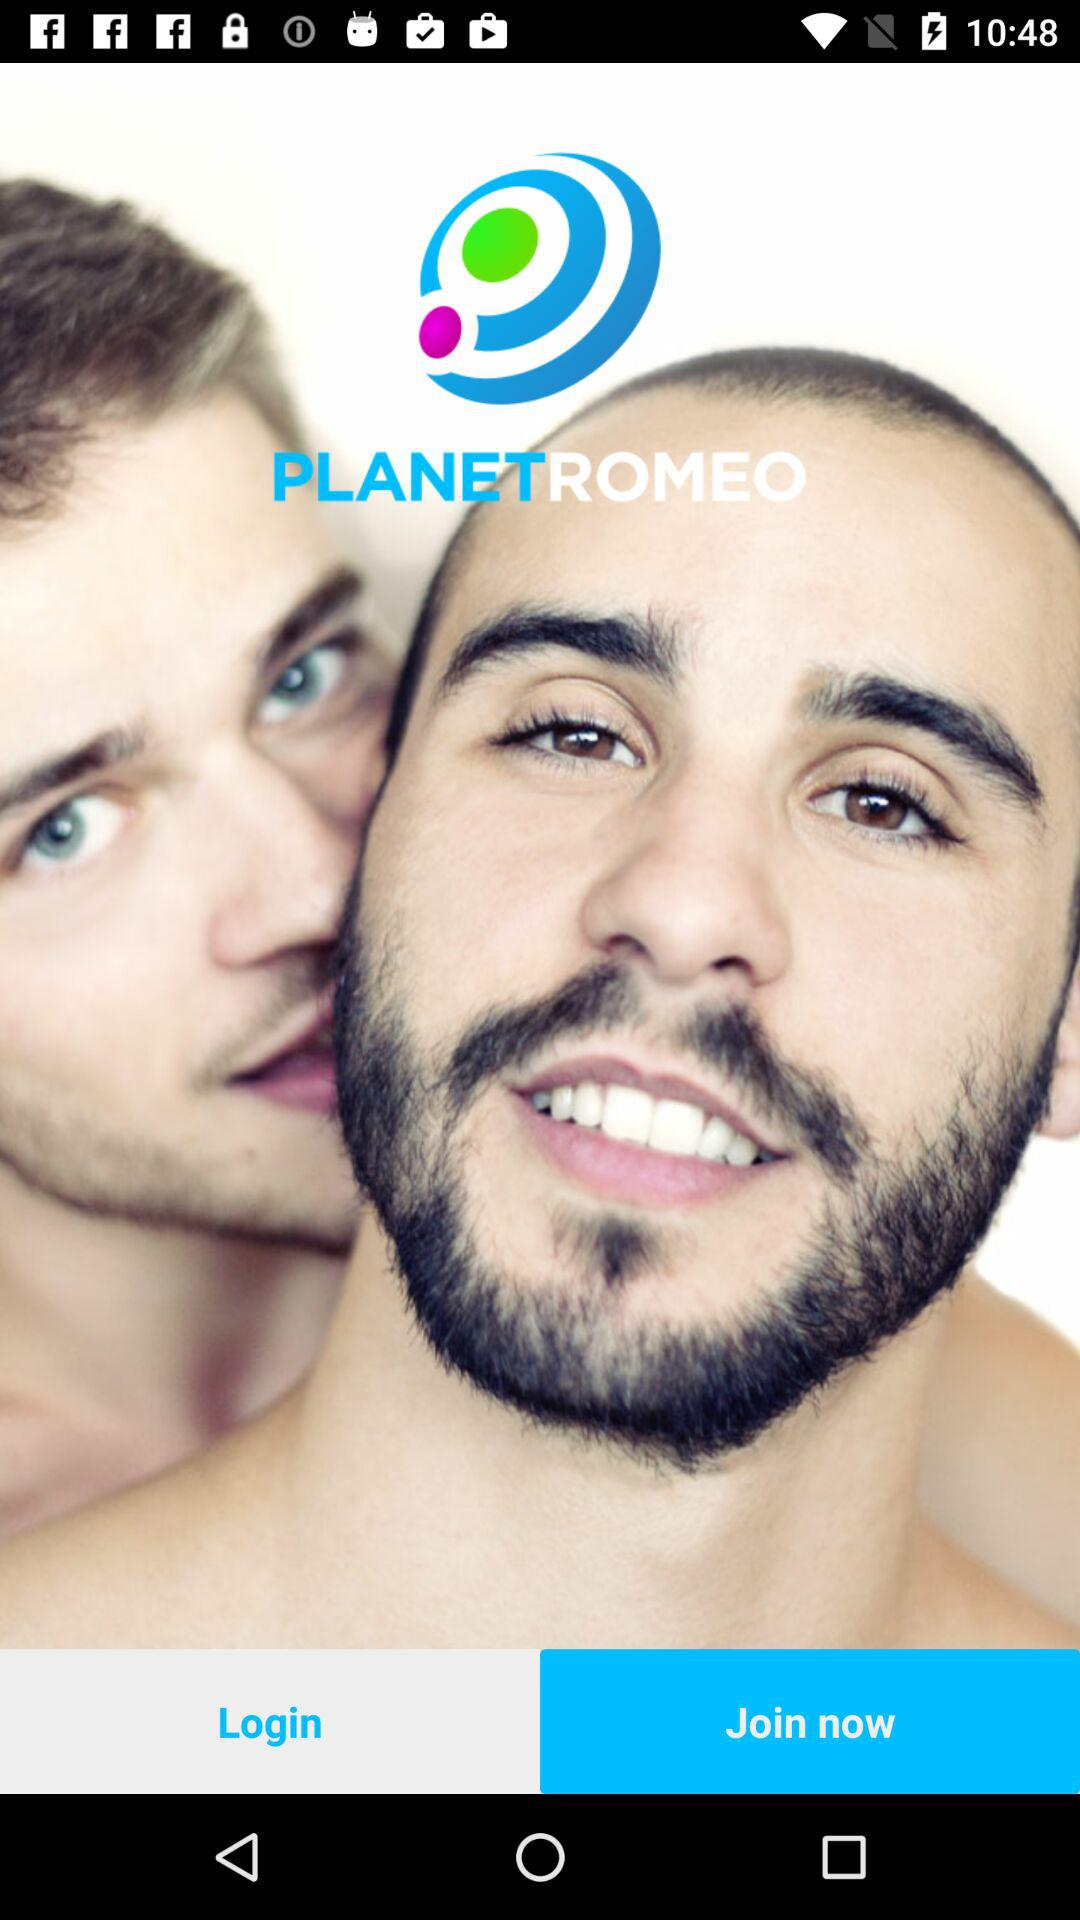What is the name of the application? The name of the application is "PLANETROMEO". 